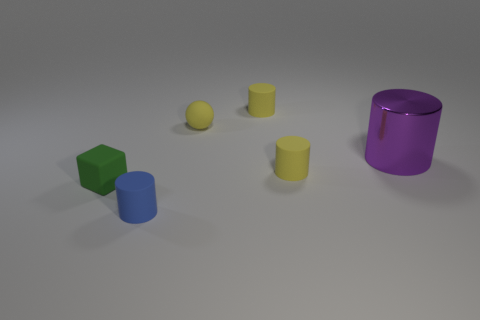Is there any other thing that is the same shape as the tiny green thing?
Ensure brevity in your answer.  No. There is a cylinder behind the large purple shiny cylinder; is it the same color as the tiny matte ball that is behind the matte cube?
Your answer should be compact. Yes. What number of objects are tiny red rubber objects or green matte blocks?
Ensure brevity in your answer.  1. What number of blue things have the same material as the yellow ball?
Offer a terse response. 1. Are there fewer blue cylinders than small red rubber balls?
Your response must be concise. No. Is the material of the tiny yellow cylinder that is behind the purple shiny cylinder the same as the cube?
Your answer should be very brief. Yes. What number of cylinders are small blue matte things or purple objects?
Provide a short and direct response. 2. What is the shape of the small object that is both on the right side of the small yellow rubber sphere and in front of the big shiny cylinder?
Provide a succinct answer. Cylinder. The thing that is in front of the green thing that is in front of the small yellow matte object in front of the small yellow sphere is what color?
Your answer should be compact. Blue. Is the number of matte things that are behind the purple object less than the number of yellow matte objects?
Provide a short and direct response. Yes. 